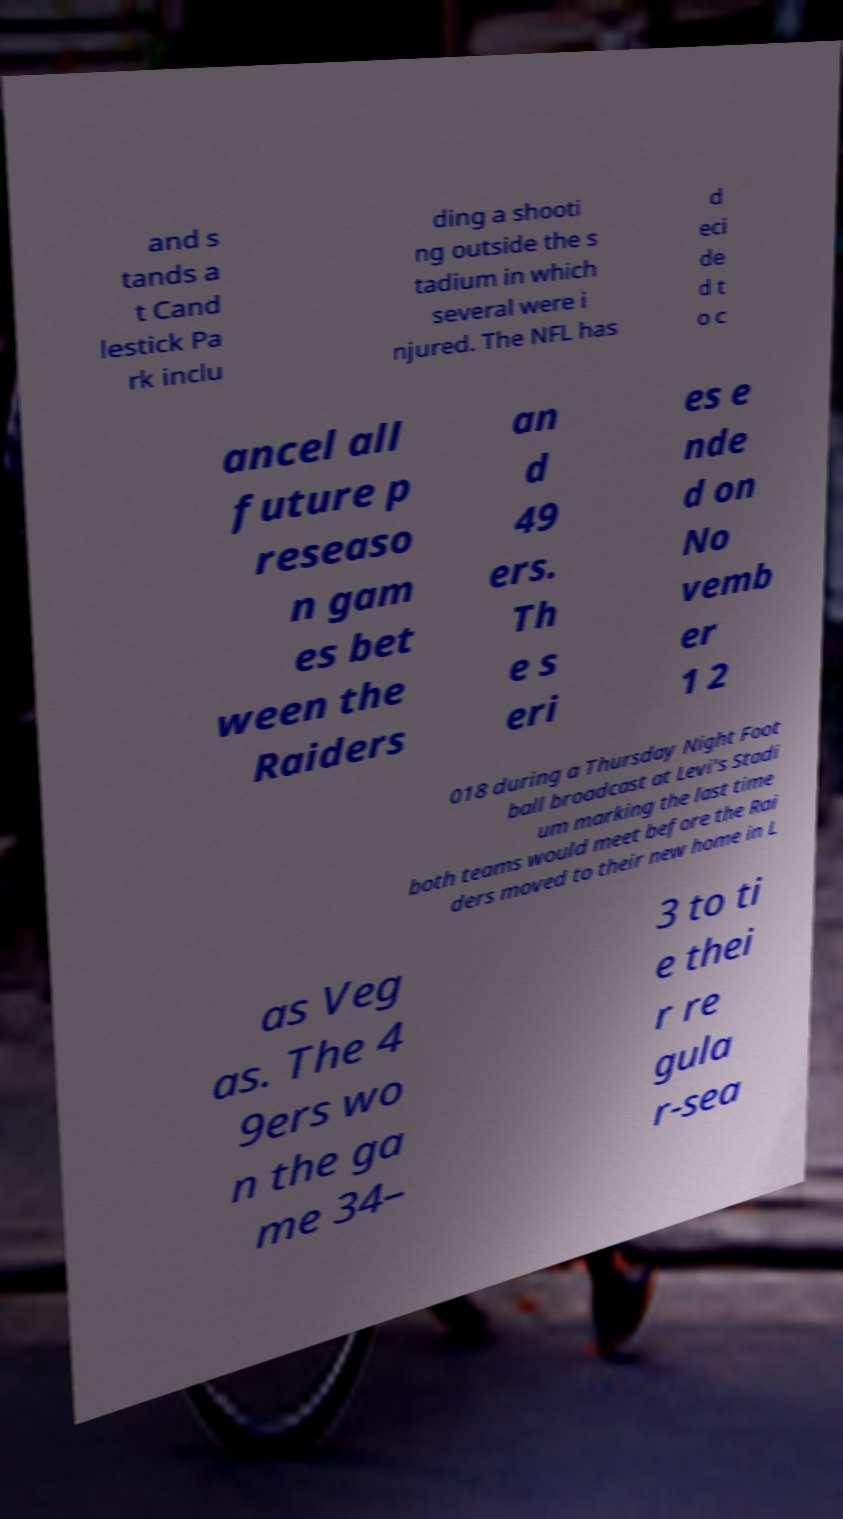For documentation purposes, I need the text within this image transcribed. Could you provide that? and s tands a t Cand lestick Pa rk inclu ding a shooti ng outside the s tadium in which several were i njured. The NFL has d eci de d t o c ancel all future p reseaso n gam es bet ween the Raiders an d 49 ers. Th e s eri es e nde d on No vemb er 1 2 018 during a Thursday Night Foot ball broadcast at Levi's Stadi um marking the last time both teams would meet before the Rai ders moved to their new home in L as Veg as. The 4 9ers wo n the ga me 34– 3 to ti e thei r re gula r-sea 